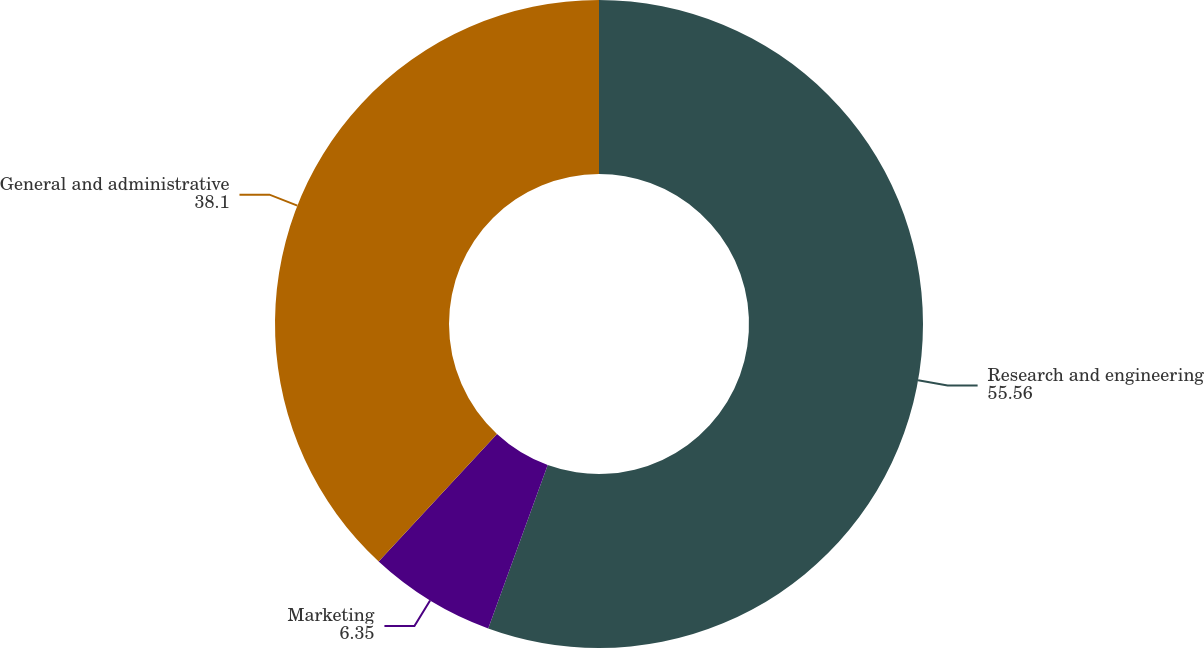<chart> <loc_0><loc_0><loc_500><loc_500><pie_chart><fcel>Research and engineering<fcel>Marketing<fcel>General and administrative<nl><fcel>55.56%<fcel>6.35%<fcel>38.1%<nl></chart> 